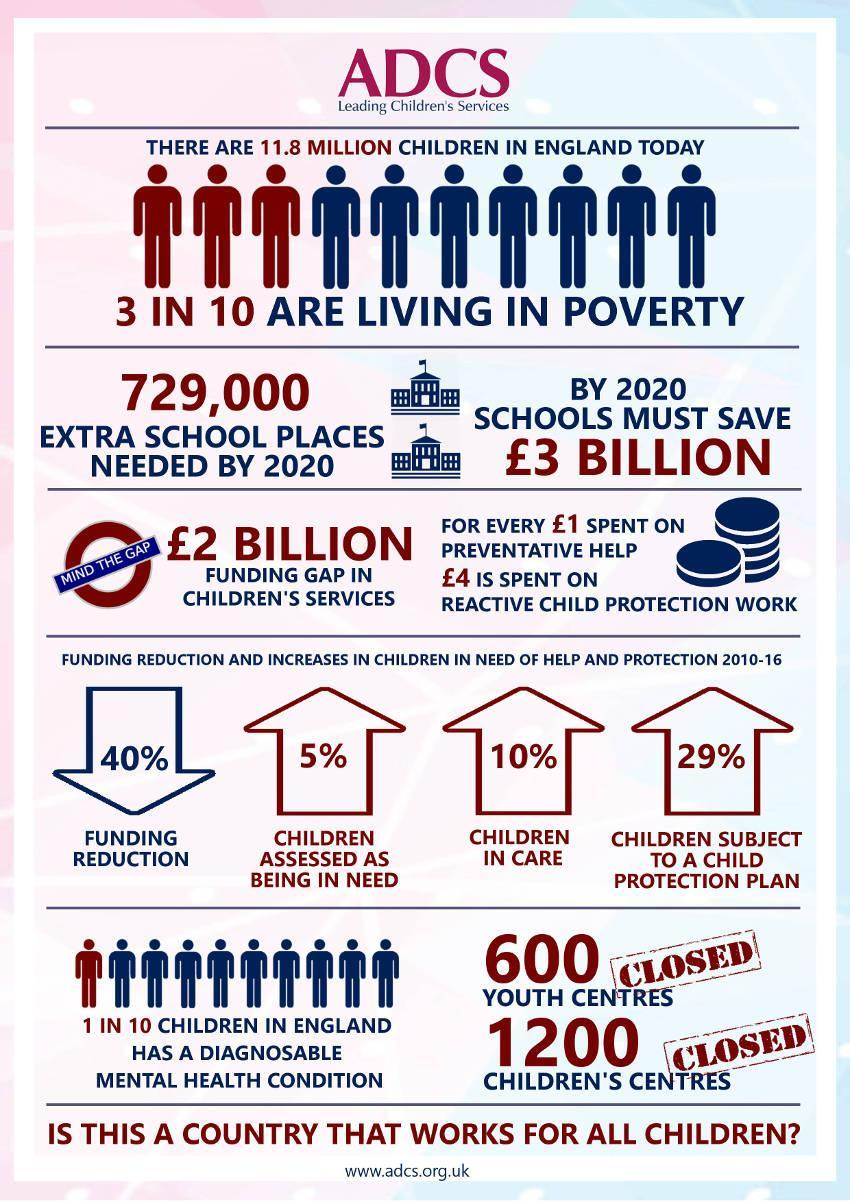What percentage of children in England are living in poverty?
Answer the question with a short phrase. 30% What number of children's centres and youth centres have been closed? 1800 Approximately what number of children among 11.8 million children in England are in poverty? 3540000 What percent of children in England have a diagnosable mental health condition? 10% What percentage of children are assessed as being in need? 5% What percentage of children are subject to a child protection plan? 29% 